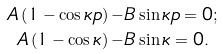<formula> <loc_0><loc_0><loc_500><loc_500>A \left ( 1 - \cos \kappa p \right ) - & B \sin \kappa p = 0 ; \\ A \left ( 1 - \cos \kappa \right ) - & B \sin \kappa = 0 .</formula> 